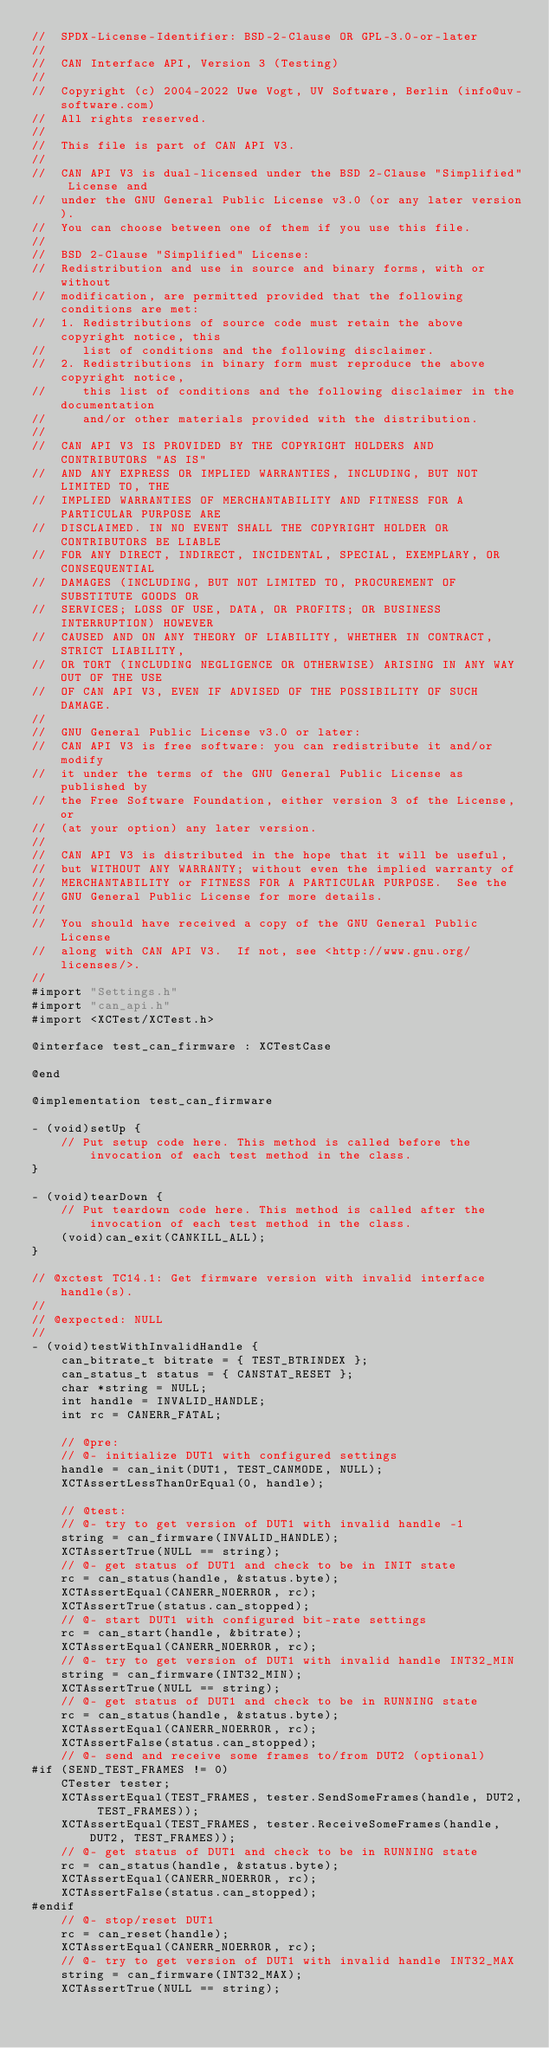<code> <loc_0><loc_0><loc_500><loc_500><_ObjectiveC_>//  SPDX-License-Identifier: BSD-2-Clause OR GPL-3.0-or-later
//
//  CAN Interface API, Version 3 (Testing)
//
//  Copyright (c) 2004-2022 Uwe Vogt, UV Software, Berlin (info@uv-software.com)
//  All rights reserved.
//
//  This file is part of CAN API V3.
//
//  CAN API V3 is dual-licensed under the BSD 2-Clause "Simplified" License and
//  under the GNU General Public License v3.0 (or any later version).
//  You can choose between one of them if you use this file.
//
//  BSD 2-Clause "Simplified" License:
//  Redistribution and use in source and binary forms, with or without
//  modification, are permitted provided that the following conditions are met:
//  1. Redistributions of source code must retain the above copyright notice, this
//     list of conditions and the following disclaimer.
//  2. Redistributions in binary form must reproduce the above copyright notice,
//     this list of conditions and the following disclaimer in the documentation
//     and/or other materials provided with the distribution.
//
//  CAN API V3 IS PROVIDED BY THE COPYRIGHT HOLDERS AND CONTRIBUTORS "AS IS"
//  AND ANY EXPRESS OR IMPLIED WARRANTIES, INCLUDING, BUT NOT LIMITED TO, THE
//  IMPLIED WARRANTIES OF MERCHANTABILITY AND FITNESS FOR A PARTICULAR PURPOSE ARE
//  DISCLAIMED. IN NO EVENT SHALL THE COPYRIGHT HOLDER OR CONTRIBUTORS BE LIABLE
//  FOR ANY DIRECT, INDIRECT, INCIDENTAL, SPECIAL, EXEMPLARY, OR CONSEQUENTIAL
//  DAMAGES (INCLUDING, BUT NOT LIMITED TO, PROCUREMENT OF SUBSTITUTE GOODS OR
//  SERVICES; LOSS OF USE, DATA, OR PROFITS; OR BUSINESS INTERRUPTION) HOWEVER
//  CAUSED AND ON ANY THEORY OF LIABILITY, WHETHER IN CONTRACT, STRICT LIABILITY,
//  OR TORT (INCLUDING NEGLIGENCE OR OTHERWISE) ARISING IN ANY WAY OUT OF THE USE
//  OF CAN API V3, EVEN IF ADVISED OF THE POSSIBILITY OF SUCH DAMAGE.
//
//  GNU General Public License v3.0 or later:
//  CAN API V3 is free software: you can redistribute it and/or modify
//  it under the terms of the GNU General Public License as published by
//  the Free Software Foundation, either version 3 of the License, or
//  (at your option) any later version.
//
//  CAN API V3 is distributed in the hope that it will be useful,
//  but WITHOUT ANY WARRANTY; without even the implied warranty of
//  MERCHANTABILITY or FITNESS FOR A PARTICULAR PURPOSE.  See the
//  GNU General Public License for more details.
//
//  You should have received a copy of the GNU General Public License
//  along with CAN API V3.  If not, see <http://www.gnu.org/licenses/>.
//
#import "Settings.h"
#import "can_api.h"
#import <XCTest/XCTest.h>

@interface test_can_firmware : XCTestCase

@end

@implementation test_can_firmware

- (void)setUp {
    // Put setup code here. This method is called before the invocation of each test method in the class.
}

- (void)tearDown {
    // Put teardown code here. This method is called after the invocation of each test method in the class.
    (void)can_exit(CANKILL_ALL);
}

// @xctest TC14.1: Get firmware version with invalid interface handle(s).
//
// @expected: NULL
//
- (void)testWithInvalidHandle {
    can_bitrate_t bitrate = { TEST_BTRINDEX };
    can_status_t status = { CANSTAT_RESET };
    char *string = NULL;
    int handle = INVALID_HANDLE;
    int rc = CANERR_FATAL;

    // @pre:
    // @- initialize DUT1 with configured settings
    handle = can_init(DUT1, TEST_CANMODE, NULL);
    XCTAssertLessThanOrEqual(0, handle);

    // @test:
    // @- try to get version of DUT1 with invalid handle -1
    string = can_firmware(INVALID_HANDLE);
    XCTAssertTrue(NULL == string);
    // @- get status of DUT1 and check to be in INIT state
    rc = can_status(handle, &status.byte);
    XCTAssertEqual(CANERR_NOERROR, rc);
    XCTAssertTrue(status.can_stopped);
    // @- start DUT1 with configured bit-rate settings
    rc = can_start(handle, &bitrate);
    XCTAssertEqual(CANERR_NOERROR, rc);
    // @- try to get version of DUT1 with invalid handle INT32_MIN
    string = can_firmware(INT32_MIN);
    XCTAssertTrue(NULL == string);
    // @- get status of DUT1 and check to be in RUNNING state
    rc = can_status(handle, &status.byte);
    XCTAssertEqual(CANERR_NOERROR, rc);
    XCTAssertFalse(status.can_stopped);
    // @- send and receive some frames to/from DUT2 (optional)
#if (SEND_TEST_FRAMES != 0)
    CTester tester;
    XCTAssertEqual(TEST_FRAMES, tester.SendSomeFrames(handle, DUT2, TEST_FRAMES));
    XCTAssertEqual(TEST_FRAMES, tester.ReceiveSomeFrames(handle, DUT2, TEST_FRAMES));
    // @- get status of DUT1 and check to be in RUNNING state
    rc = can_status(handle, &status.byte);
    XCTAssertEqual(CANERR_NOERROR, rc);
    XCTAssertFalse(status.can_stopped);
#endif
    // @- stop/reset DUT1
    rc = can_reset(handle);
    XCTAssertEqual(CANERR_NOERROR, rc);
    // @- try to get version of DUT1 with invalid handle INT32_MAX
    string = can_firmware(INT32_MAX);
    XCTAssertTrue(NULL == string);</code> 